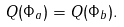<formula> <loc_0><loc_0><loc_500><loc_500>Q ( \Phi _ { a } ) = Q ( \Phi _ { b } ) .</formula> 